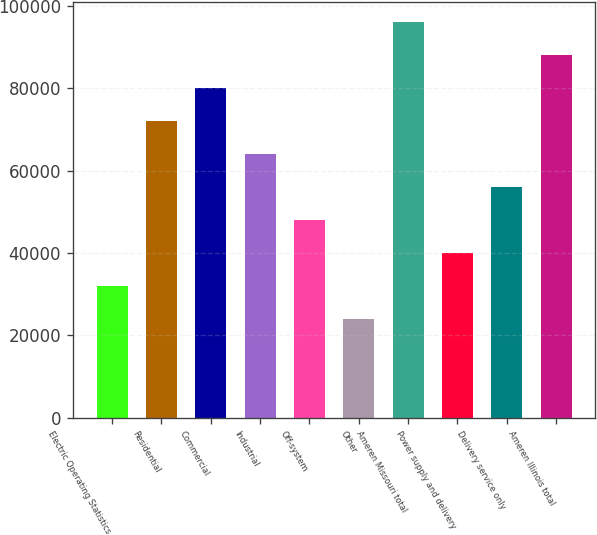Convert chart to OTSL. <chart><loc_0><loc_0><loc_500><loc_500><bar_chart><fcel>Electric Operating Statistics<fcel>Residential<fcel>Commercial<fcel>Industrial<fcel>Off-system<fcel>Other<fcel>Ameren Missouri total<fcel>Power supply and delivery<fcel>Delivery service only<fcel>Ameren Illinois total<nl><fcel>32012.6<fcel>72004.6<fcel>80003<fcel>64006.2<fcel>48009.4<fcel>24014.2<fcel>95999.8<fcel>40011<fcel>56007.8<fcel>88001.4<nl></chart> 